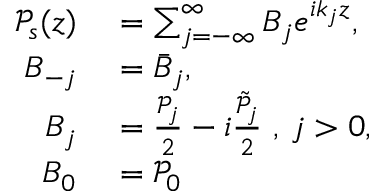Convert formula to latex. <formula><loc_0><loc_0><loc_500><loc_500>\begin{array} { r l } { \mathcal { P } _ { s } ( z ) } & = \sum _ { j = - \infty } ^ { \infty } B _ { j } e ^ { i k _ { j } z } , } \\ { B _ { - j } } & = \bar { B } _ { j } , } \\ { B _ { j } } & = \frac { \mathcal { P } _ { j } } { 2 } - i \frac { \tilde { \mathcal { P } } _ { j } } { 2 } , j > 0 , } \\ { B _ { 0 } } & = \mathcal { P } _ { 0 } } \end{array}</formula> 